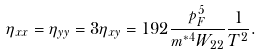Convert formula to latex. <formula><loc_0><loc_0><loc_500><loc_500>\eta _ { x x } = \eta _ { y y } = 3 \eta _ { x y } = 1 9 2 \frac { p _ { F } ^ { 5 } } { m ^ { * 4 } W _ { 2 2 } } \frac { 1 } { T ^ { 2 } } .</formula> 